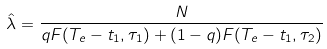Convert formula to latex. <formula><loc_0><loc_0><loc_500><loc_500>\hat { \lambda } = \frac { N } { q F ( T _ { e } - t _ { 1 } , \tau _ { 1 } ) + ( 1 - q ) F ( T _ { e } - t _ { 1 } , \tau _ { 2 } ) }</formula> 